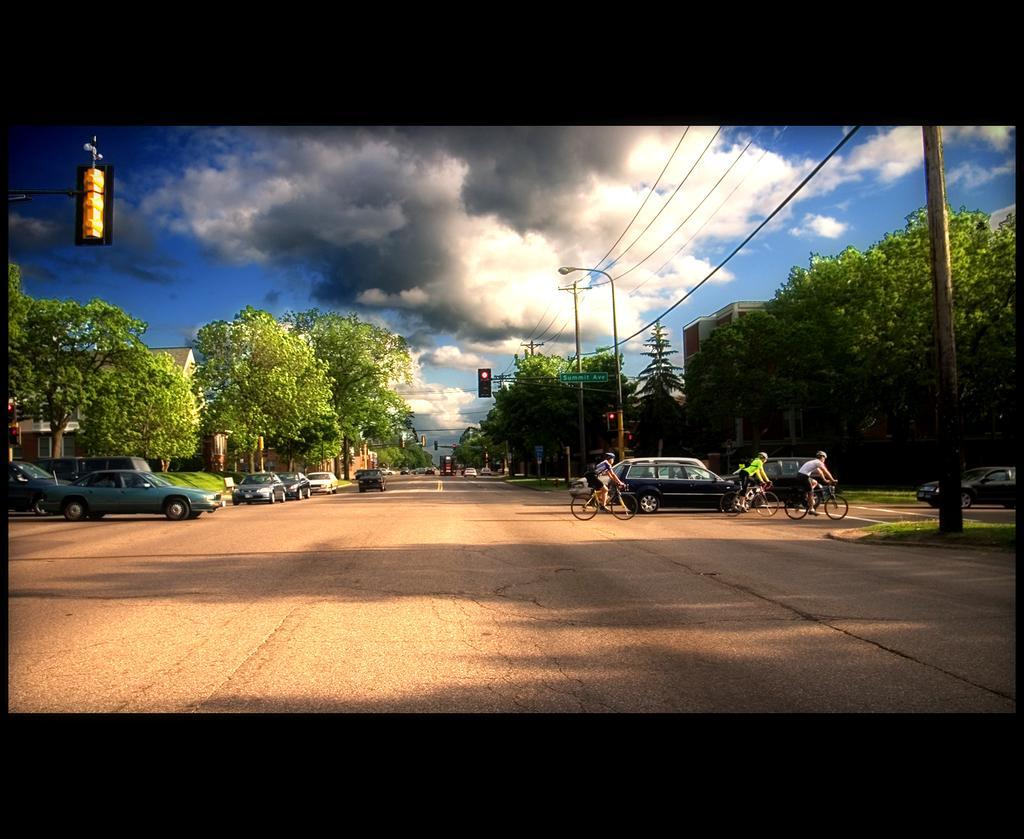Describe this image in one or two sentences. In this image there are vehicles and there are persons riding bicycle. There are trees, poles and there is grass on the ground and the sky is cloudy. 